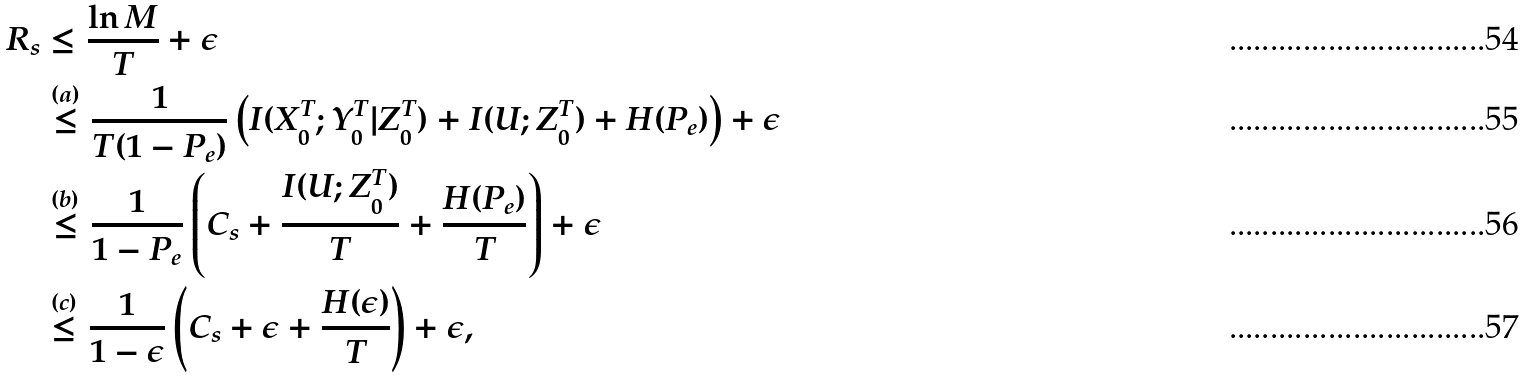<formula> <loc_0><loc_0><loc_500><loc_500>R _ { s } & \leq \frac { \ln M } { T } + \epsilon \\ & \stackrel { ( a ) } { \leq } \frac { 1 } { T ( 1 - P _ { e } ) } \left ( I ( X _ { 0 } ^ { T } ; Y _ { 0 } ^ { T } | Z _ { 0 } ^ { T } ) + I ( U ; Z _ { 0 } ^ { T } ) + H ( P _ { e } ) \right ) + \epsilon \\ & \stackrel { ( b ) } { \leq } \frac { 1 } { 1 - P _ { e } } \left ( C _ { s } + \frac { I ( U ; Z _ { 0 } ^ { T } ) } { T } + \frac { H ( P _ { e } ) } { T } \right ) + \epsilon \\ & \stackrel { ( c ) } { \leq } \frac { 1 } { 1 - \epsilon } \left ( C _ { s } + \epsilon + \frac { H ( \epsilon ) } { T } \right ) + \epsilon ,</formula> 